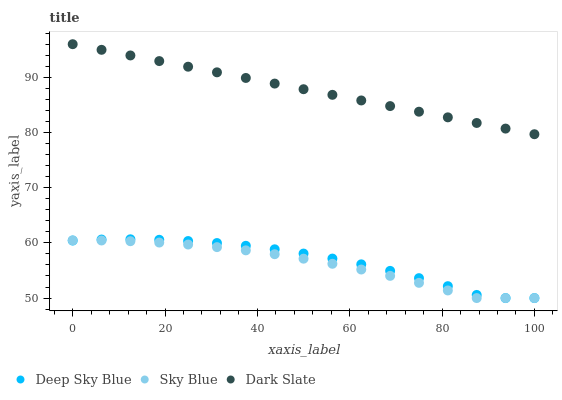Does Sky Blue have the minimum area under the curve?
Answer yes or no. Yes. Does Dark Slate have the maximum area under the curve?
Answer yes or no. Yes. Does Deep Sky Blue have the minimum area under the curve?
Answer yes or no. No. Does Deep Sky Blue have the maximum area under the curve?
Answer yes or no. No. Is Dark Slate the smoothest?
Answer yes or no. Yes. Is Deep Sky Blue the roughest?
Answer yes or no. Yes. Is Deep Sky Blue the smoothest?
Answer yes or no. No. Is Dark Slate the roughest?
Answer yes or no. No. Does Sky Blue have the lowest value?
Answer yes or no. Yes. Does Dark Slate have the lowest value?
Answer yes or no. No. Does Dark Slate have the highest value?
Answer yes or no. Yes. Does Deep Sky Blue have the highest value?
Answer yes or no. No. Is Sky Blue less than Dark Slate?
Answer yes or no. Yes. Is Dark Slate greater than Deep Sky Blue?
Answer yes or no. Yes. Does Deep Sky Blue intersect Sky Blue?
Answer yes or no. Yes. Is Deep Sky Blue less than Sky Blue?
Answer yes or no. No. Is Deep Sky Blue greater than Sky Blue?
Answer yes or no. No. Does Sky Blue intersect Dark Slate?
Answer yes or no. No. 